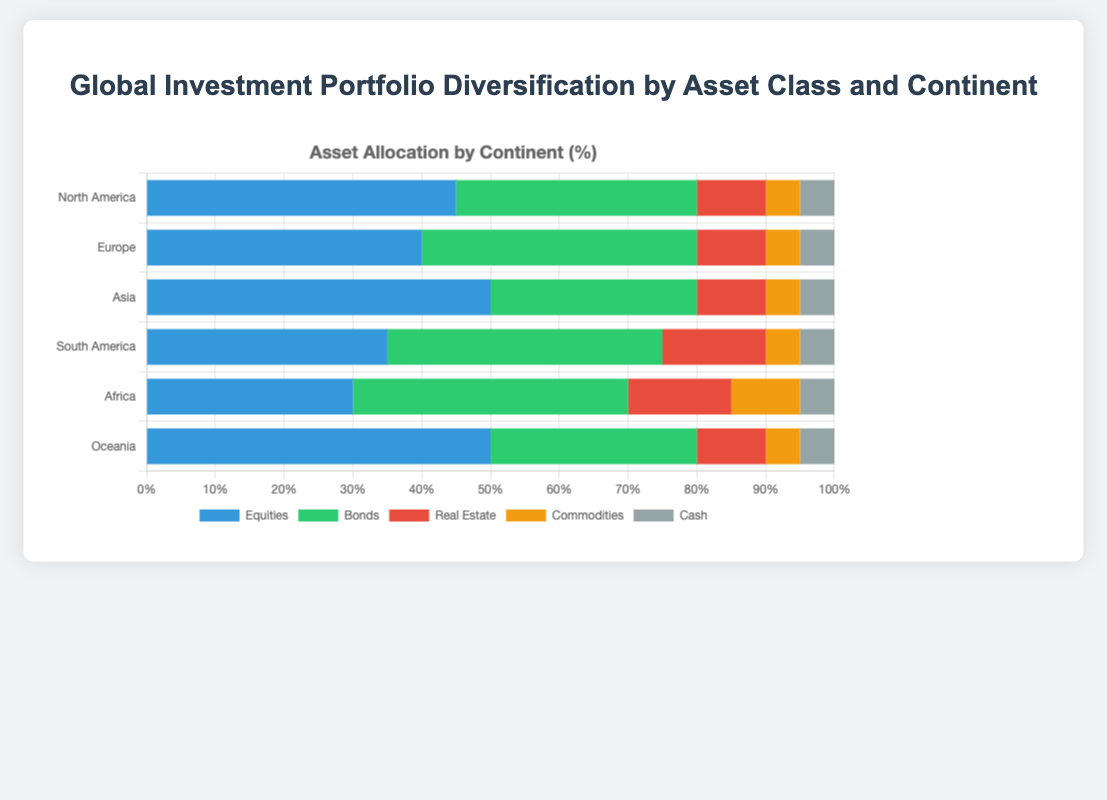What is the total percentage of bonds in South America and Africa? The percentage of bonds in South America is 40%, and the percentage of bonds in Africa is 40%. Adding them together, 40 + 40 = 80.
Answer: 80% Which continent has the highest allocation in equities? By comparing the equity allocations, North America has 45%, Europe has 40%, Asia has 50%, South America has 35%, Africa has 30%, and Oceania has 50%. Both Asia and Oceania have the highest allocation at 50%.
Answer: Asia and Oceania In Europe, what is the difference between the allocation in bonds and equities? The allocation for bonds in Europe is 40%, and for equities, it is also 40%. The difference is 40 - 40 = 0.
Answer: 0% Which two continents have the same percentage allocation in real estate? Examining the real estate allocation: North America has 10%, Europe has 10%, Asia has 10%, South America has 15%, Africa has 15%, and Oceania has 10%. North America, Europe, Asia, and Oceania all have the same allocation of 10%.
Answer: North America, Europe, Asia, and Oceania What is the average percentage allocation in commodities across all continents? Summing the allocations in commodities: North America 5%, Europe 5%, Asia 5%, South America 5%, Africa 10%, Oceania 5%. The sum is 5 + 5 + 5 + 5 + 10 + 5 = 35. There are 6 continents, so the average is 35 / 6 ≈ 5.83.
Answer: 5.83% Which asset class has the smallest variation in allocation percentages among all continents? Evaluating the variation for each asset class: Equities (45, 40, 50, 35, 30, 50), Bonds (35, 40, 30, 40, 40, 30), Real Estate (10, 10, 10, 15, 15, 10), Commodities (5, 5, 5, 5, 10, 5), Cash (5, 5, 5, 5, 5, 5). Commodities and cash both show minimal variation, but cash remains constant at 5% for all continents.
Answer: Cash How much higher is the allocation in real estate in South America compared to North America? South America has 15% in real estate, and North America has 10%. The difference is 15 - 10 = 5.
Answer: 5% Which continent displays the highest commodity allocation, and what is that percentage? Reviewing the commodity allocations: North America 5%, Europe 5%, Asia 5%, South America 5%, Africa 10%, Oceania 5%. Africa has the highest allocation at 10%.
Answer: Africa, 10% How does the bond allocation in North America compare to that in Asia? North America's bond allocation is 35%, and Asia's is 30%. North America's allocation is 5% higher.
Answer: North America by 5% 